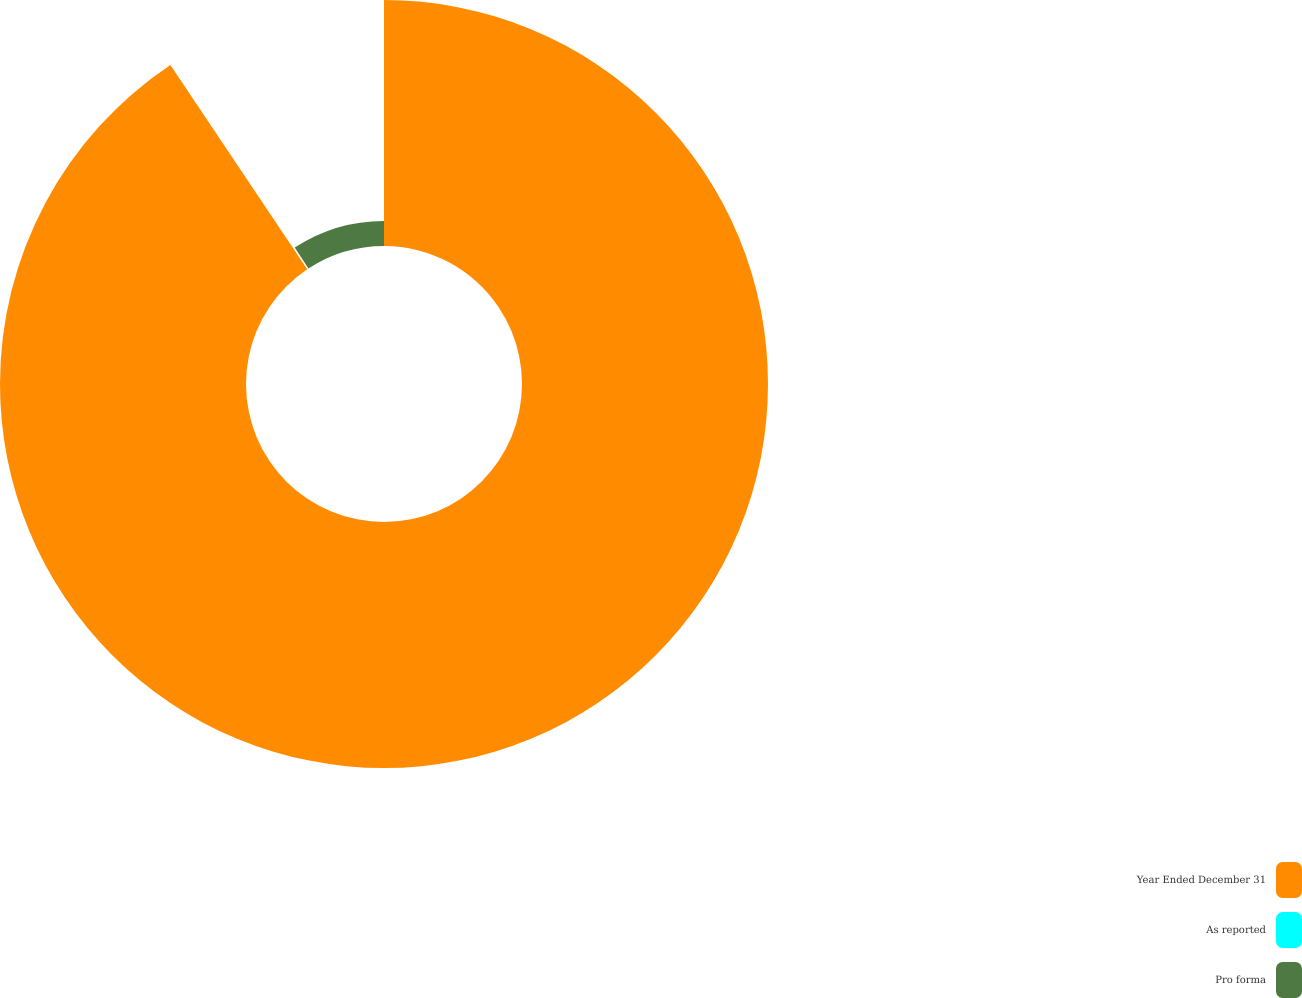Convert chart. <chart><loc_0><loc_0><loc_500><loc_500><pie_chart><fcel>Year Ended December 31<fcel>As reported<fcel>Pro forma<nl><fcel>90.61%<fcel>0.17%<fcel>9.22%<nl></chart> 